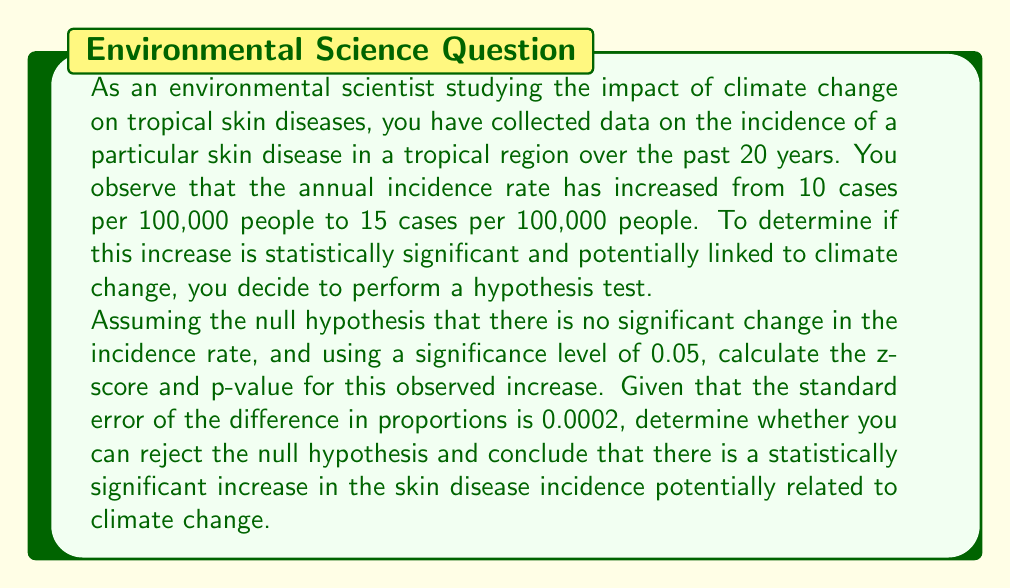Help me with this question. To determine the statistical significance of the change in skin disease incidence, we'll follow these steps:

1. Calculate the z-score for the observed difference in proportions.
2. Find the p-value associated with this z-score.
3. Compare the p-value to the significance level to make a decision.

Step 1: Calculate the z-score

The z-score formula for comparing two proportions is:

$$ z = \frac{p_2 - p_1}{\sqrt{SE^2}} $$

Where:
$p_1$ = initial proportion (10/100,000 = 0.0001)
$p_2$ = final proportion (15/100,000 = 0.00015)
$SE$ = standard error of the difference in proportions (given as 0.0002)

Plugging in the values:

$$ z = \frac{0.00015 - 0.0001}{0.0002} = \frac{0.00005}{0.0002} = 0.25 $$

Step 2: Find the p-value

The p-value is the probability of obtaining a result as extreme as the observed result, assuming the null hypothesis is true. For a two-tailed test, we need to find the area under both tails of the normal distribution beyond the calculated z-score.

Using a standard normal distribution table or calculator:

p-value = $2 \times P(Z > 0.25)$ = $2 \times 0.4013 = 0.8026$

Step 3: Compare the p-value to the significance level

The calculated p-value (0.8026) is much larger than the significance level (0.05).

Therefore, we fail to reject the null hypothesis. There is not enough evidence to conclude that there is a statistically significant increase in the skin disease incidence that could be potentially related to climate change.
Answer: Fail to reject the null hypothesis. The z-score is 0.25, and the p-value is 0.8026, which is greater than the significance level of 0.05. There is insufficient evidence to conclude a statistically significant increase in skin disease incidence potentially related to climate change. 